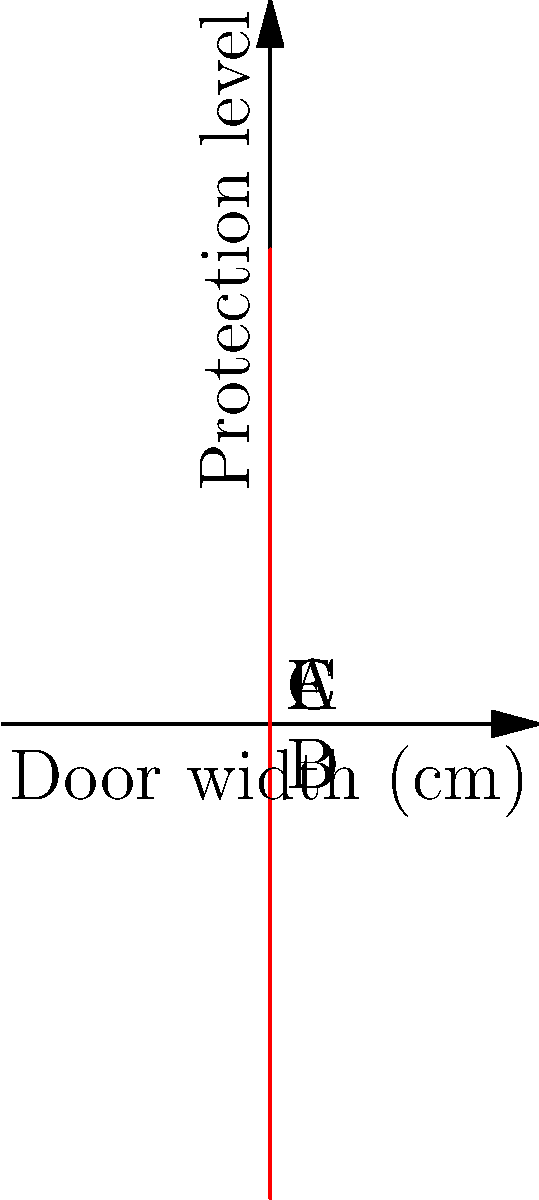The graph represents a fifth-degree polynomial modeling the side-impact protection curve for a car door. Points A, B, C, D, and E correspond to specific structural elements. Which point represents the optimal location for the main impact beam to maximize protection while minimizing weight? To determine the optimal location for the main impact beam, we need to analyze the curve:

1. The y-axis represents the protection level, while the x-axis shows the door width.
2. We're looking for a point that provides high protection (y-value) without being too far into the door (x-value).
3. Examining the points:
   A (50cm): High protection but too close to the outer skin.
   B (100cm): Lower protection, not ideal.
   C (150cm): Highest protection level among all points.
   D (200cm): Lower protection, too deep into the door.
   E (250cm): High protection but too close to the inner panel.
4. Point C (150cm) offers the highest protection level and is located near the middle of the door width.
5. This location balances maximum protection with optimal weight distribution.

Therefore, point C represents the ideal location for the main impact beam.
Answer: Point C (150cm) 